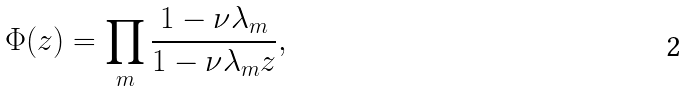Convert formula to latex. <formula><loc_0><loc_0><loc_500><loc_500>\Phi ( z ) = \prod _ { m } \frac { 1 - \nu \lambda _ { m } } { 1 - \nu \lambda _ { m } z } ,</formula> 